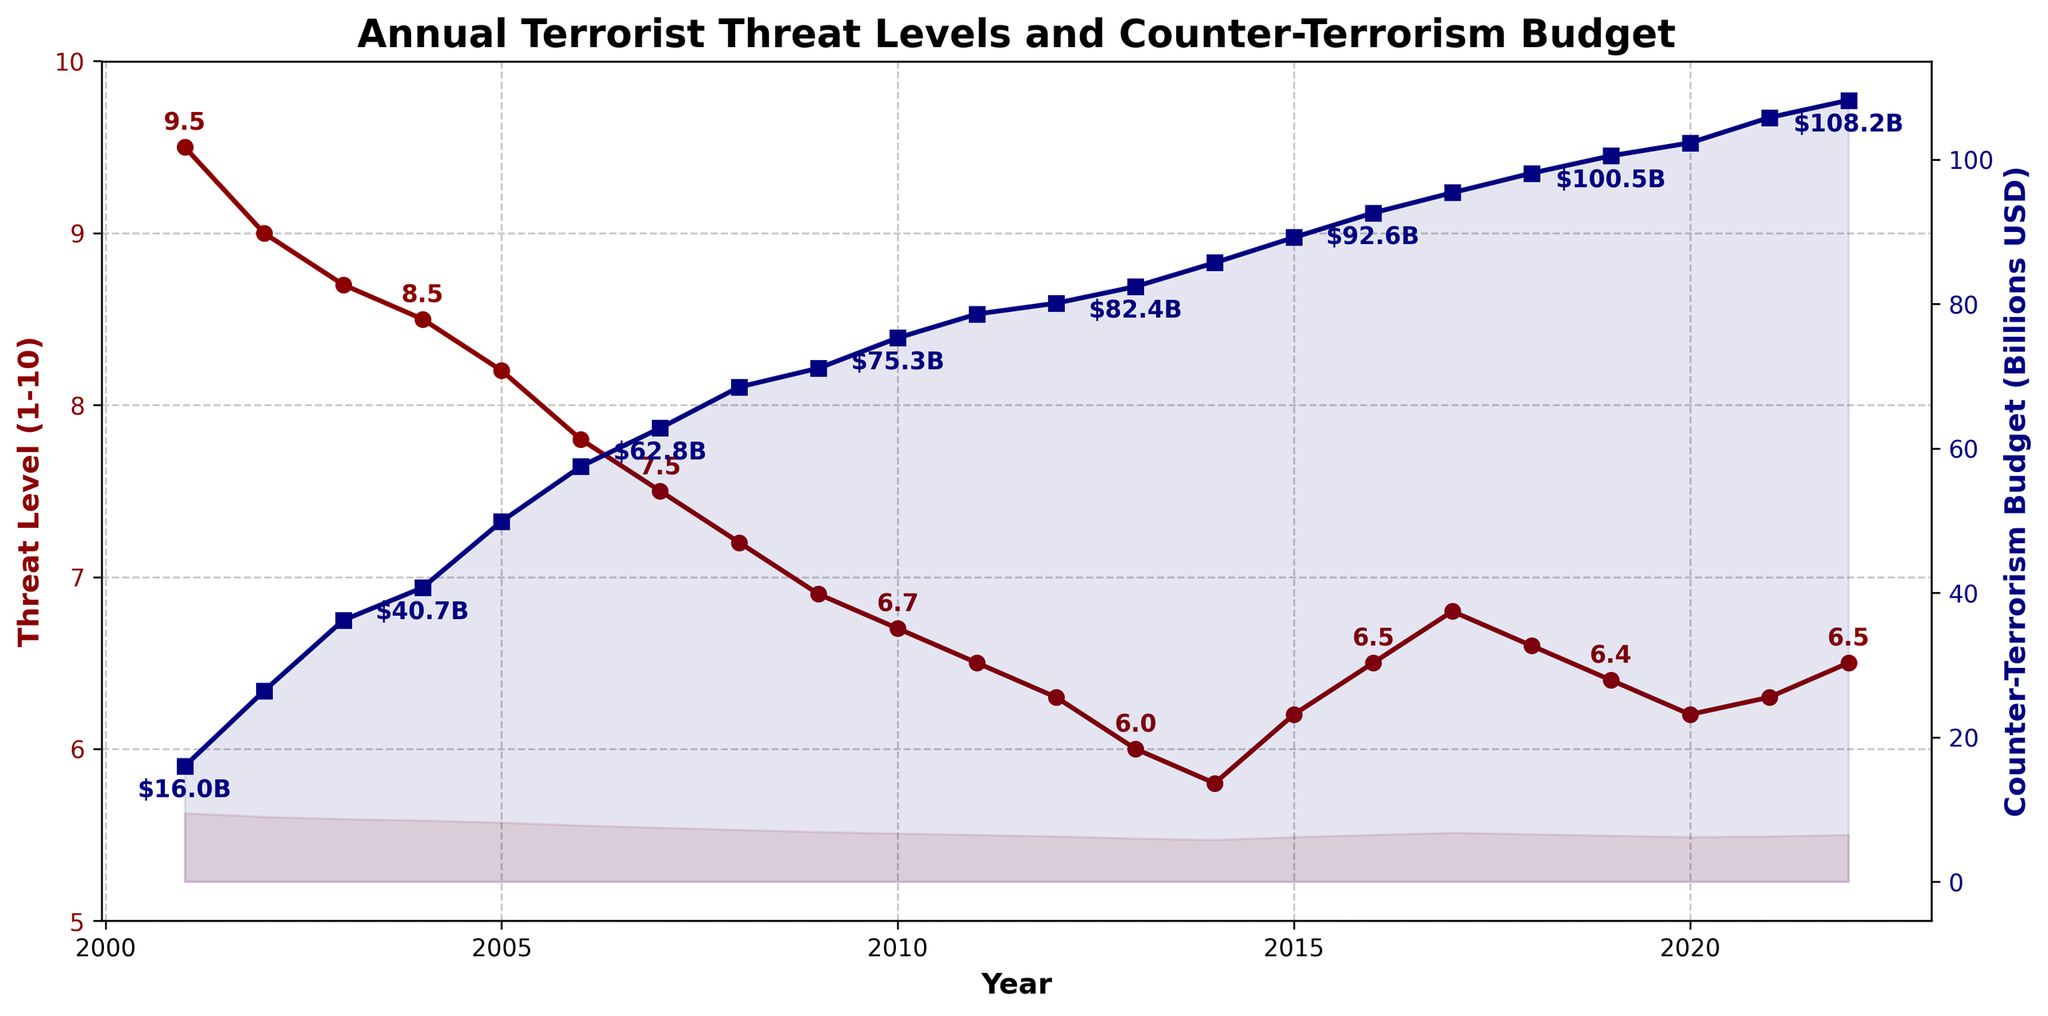What was the highest annual terrorist threat level between 2001 and 2022? The highest terrorist threat level can be observed by looking at the red line representing 'Threat Level (1-10)' and identifying the peak value. The red line peaks at a value of 9.5 in 2001.
Answer: 9.5 In which year did the counter-terrorism budget experience the largest annual increase? To determine this, we check the increments between adjacent points of the blue line representing 'Counter-Terrorism Budget (Billions USD)'. The largest increase occurred between 2001 and 2002, where the budget increased from 16.0 to 26.4 billion USD, a change of 10.4 billion USD.
Answer: 2002 What was the average threat level from 2010 to 2015? First, identify the threat levels for the years 2010 through 2015: 6.7, 6.5, 6.3, 6.0, 5.8, and 6.2. Adding these values: 6.7 + 6.5 + 6.3 + 6.0 + 5.8 + 6.2 = 37.5. Then, divide by the number of years (6) to find the average: 37.5 / 6 = 6.25.
Answer: 6.25 By how much did the counter-terrorism budget increase from 2001 to 2022? Compare the budget figures for 2001 and 2022. The budget in 2001 was 16.0 billion USD, and in 2022 it was 108.2 billion USD. The increase is 108.2 - 16.0 = 92.2 billion USD.
Answer: 92.2 billion USD How did the threat level change from 2001 to 2022? Observe the red line representing 'Threat Level (1-10)' from 2001 to 2022. The threat level started at 9.5 in 2001 and ended at 6.5 in 2022. This indicates a decline of 9.5 - 6.5 = 3.0 points.
Answer: 3.0 points decrease What is the difference between the highest and lowest annual counter-terrorism budgets between 2001 and 2022? Identify the highest and lowest budget values. The highest budget is 108.2 billion USD (2022) and the lowest is 16.0 billion USD (2001). The difference is 108.2 - 16.0 = 92.2 billion USD.
Answer: 92.2 billion USD What color represents the counter-terrorism budget on the plot? The counter-terrorism budget is represented by a blue line on the plot.
Answer: Blue Did the threat level ever increase consecutively for three years? If yes, in which years? To determine this, scan the red line's values for any consistent increase over three consecutive years. Between 2015 and 2017, the threat level increased from 6.2 to 6.5 to 6.8.
Answer: 2015-2017 What was the counter-terrorism budget in 2015, and how does it compare to that in 2005? The budget in 2015 is 89.2 billion USD, while in 2005 it was 49.9 billion USD. Comparing these values, 89.2 - 49.9 = 39.3 billion USD higher in 2015.
Answer: 39.3 billion USD higher 